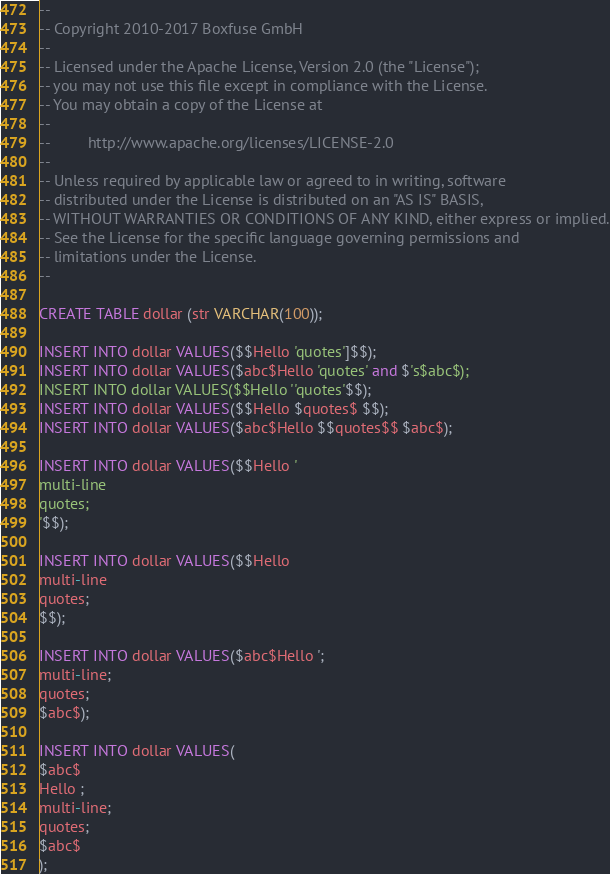<code> <loc_0><loc_0><loc_500><loc_500><_SQL_>--
-- Copyright 2010-2017 Boxfuse GmbH
--
-- Licensed under the Apache License, Version 2.0 (the "License");
-- you may not use this file except in compliance with the License.
-- You may obtain a copy of the License at
--
--         http://www.apache.org/licenses/LICENSE-2.0
--
-- Unless required by applicable law or agreed to in writing, software
-- distributed under the License is distributed on an "AS IS" BASIS,
-- WITHOUT WARRANTIES OR CONDITIONS OF ANY KIND, either express or implied.
-- See the License for the specific language governing permissions and
-- limitations under the License.
--

CREATE TABLE dollar (str VARCHAR(100));

INSERT INTO dollar VALUES($$Hello 'quotes']$$);
INSERT INTO dollar VALUES($abc$Hello 'quotes' and $'s$abc$);
INSERT INTO dollar VALUES($$Hello ''quotes'$$);
INSERT INTO dollar VALUES($$Hello $quotes$ $$);
INSERT INTO dollar VALUES($abc$Hello $$quotes$$ $abc$);

INSERT INTO dollar VALUES($$Hello '
multi-line
quotes;
'$$);

INSERT INTO dollar VALUES($$Hello
multi-line
quotes;
$$);

INSERT INTO dollar VALUES($abc$Hello ';
multi-line;
quotes;
$abc$);

INSERT INTO dollar VALUES(
$abc$
Hello ;
multi-line;
quotes;
$abc$
);</code> 